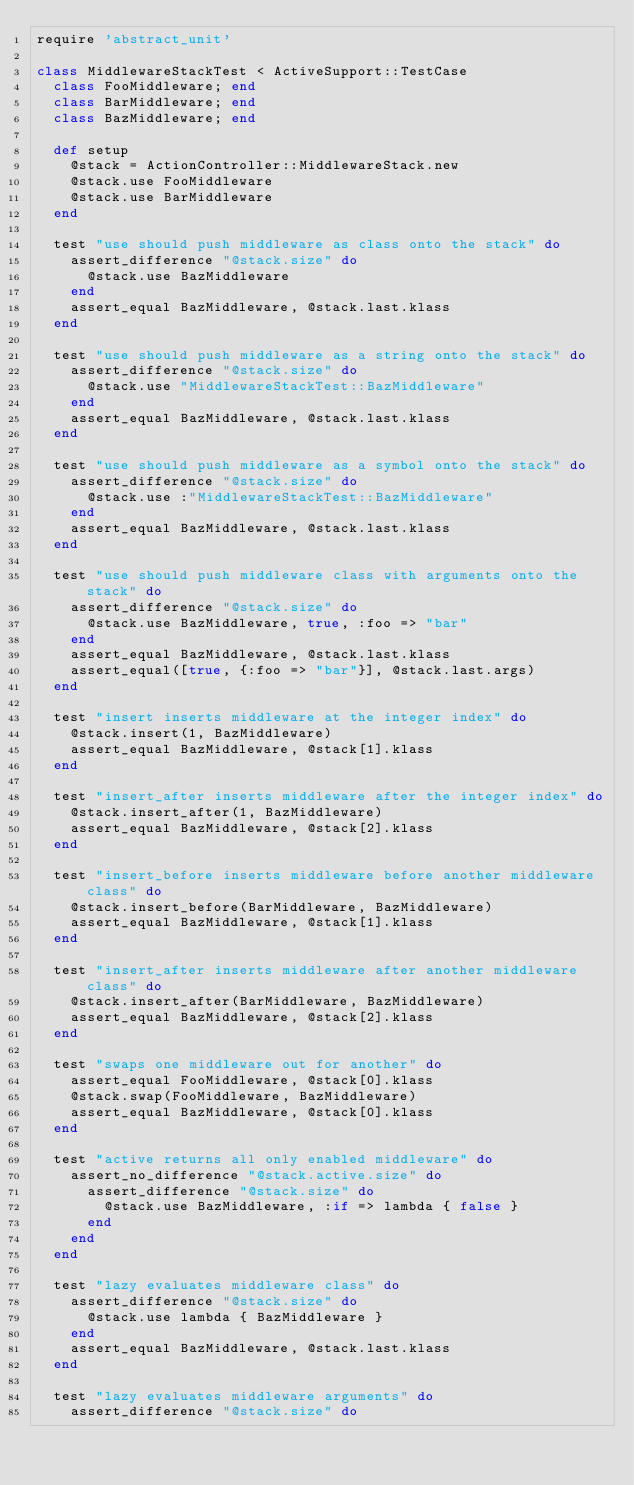Convert code to text. <code><loc_0><loc_0><loc_500><loc_500><_Ruby_>require 'abstract_unit'

class MiddlewareStackTest < ActiveSupport::TestCase
  class FooMiddleware; end
  class BarMiddleware; end
  class BazMiddleware; end

  def setup
    @stack = ActionController::MiddlewareStack.new
    @stack.use FooMiddleware
    @stack.use BarMiddleware
  end

  test "use should push middleware as class onto the stack" do
    assert_difference "@stack.size" do
      @stack.use BazMiddleware
    end
    assert_equal BazMiddleware, @stack.last.klass
  end

  test "use should push middleware as a string onto the stack" do
    assert_difference "@stack.size" do
      @stack.use "MiddlewareStackTest::BazMiddleware"
    end
    assert_equal BazMiddleware, @stack.last.klass
  end

  test "use should push middleware as a symbol onto the stack" do
    assert_difference "@stack.size" do
      @stack.use :"MiddlewareStackTest::BazMiddleware"
    end
    assert_equal BazMiddleware, @stack.last.klass
  end

  test "use should push middleware class with arguments onto the stack" do
    assert_difference "@stack.size" do
      @stack.use BazMiddleware, true, :foo => "bar"
    end
    assert_equal BazMiddleware, @stack.last.klass
    assert_equal([true, {:foo => "bar"}], @stack.last.args)
  end

  test "insert inserts middleware at the integer index" do
    @stack.insert(1, BazMiddleware)
    assert_equal BazMiddleware, @stack[1].klass
  end

  test "insert_after inserts middleware after the integer index" do
    @stack.insert_after(1, BazMiddleware)
    assert_equal BazMiddleware, @stack[2].klass
  end

  test "insert_before inserts middleware before another middleware class" do
    @stack.insert_before(BarMiddleware, BazMiddleware)
    assert_equal BazMiddleware, @stack[1].klass
  end

  test "insert_after inserts middleware after another middleware class" do
    @stack.insert_after(BarMiddleware, BazMiddleware)
    assert_equal BazMiddleware, @stack[2].klass
  end

  test "swaps one middleware out for another" do
    assert_equal FooMiddleware, @stack[0].klass
    @stack.swap(FooMiddleware, BazMiddleware)
    assert_equal BazMiddleware, @stack[0].klass
  end

  test "active returns all only enabled middleware" do
    assert_no_difference "@stack.active.size" do
      assert_difference "@stack.size" do
        @stack.use BazMiddleware, :if => lambda { false }
      end
    end
  end

  test "lazy evaluates middleware class" do
    assert_difference "@stack.size" do
      @stack.use lambda { BazMiddleware }
    end
    assert_equal BazMiddleware, @stack.last.klass
  end

  test "lazy evaluates middleware arguments" do
    assert_difference "@stack.size" do</code> 